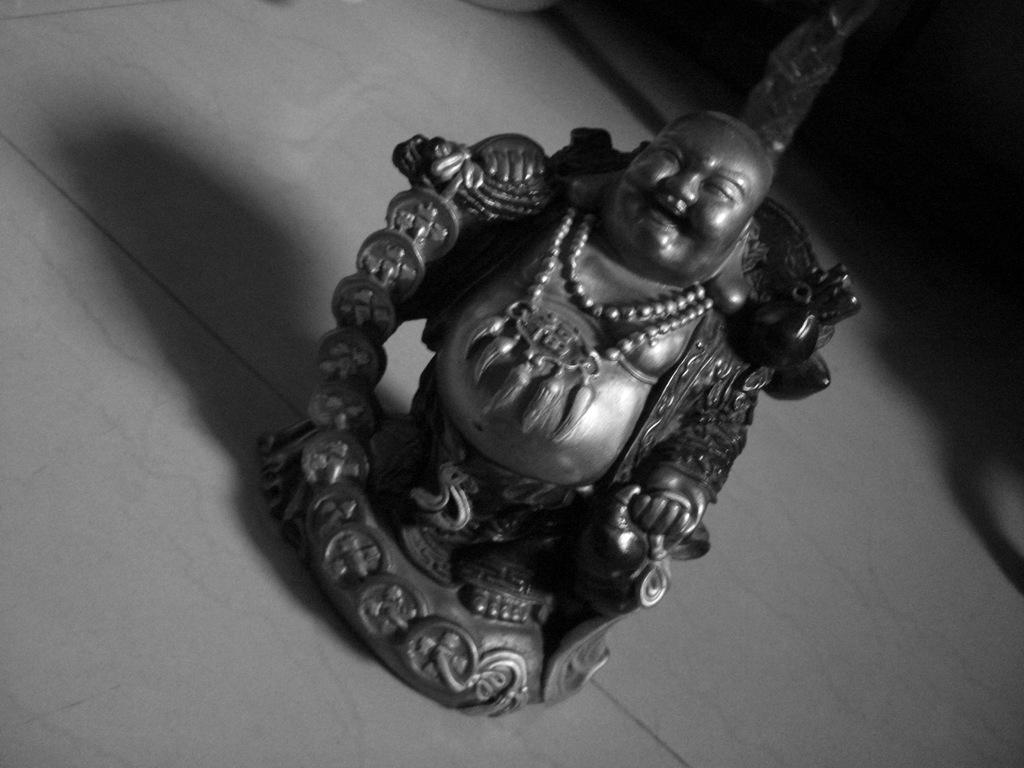What is the main subject of the image? There is a sculpture of a laughing Buddha in the image. Where is the sculpture located? The sculpture is on the floor. What type of flooring is visible in the image? There are marble tiles at the bottom of the image. What type of cherry is being used as a decoration on the laughing Buddha's head in the image? There is no cherry present on the laughing Buddha's head in the image. 